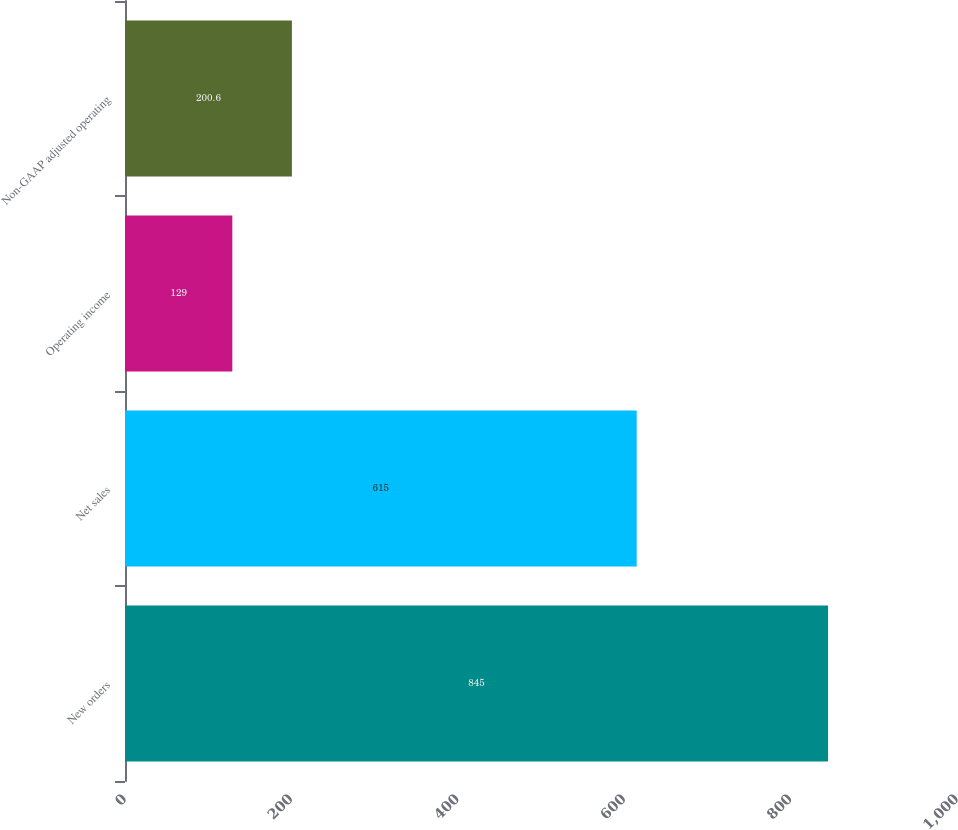Convert chart. <chart><loc_0><loc_0><loc_500><loc_500><bar_chart><fcel>New orders<fcel>Net sales<fcel>Operating income<fcel>Non-GAAP adjusted operating<nl><fcel>845<fcel>615<fcel>129<fcel>200.6<nl></chart> 